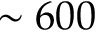<formula> <loc_0><loc_0><loc_500><loc_500>\sim 6 0 0</formula> 